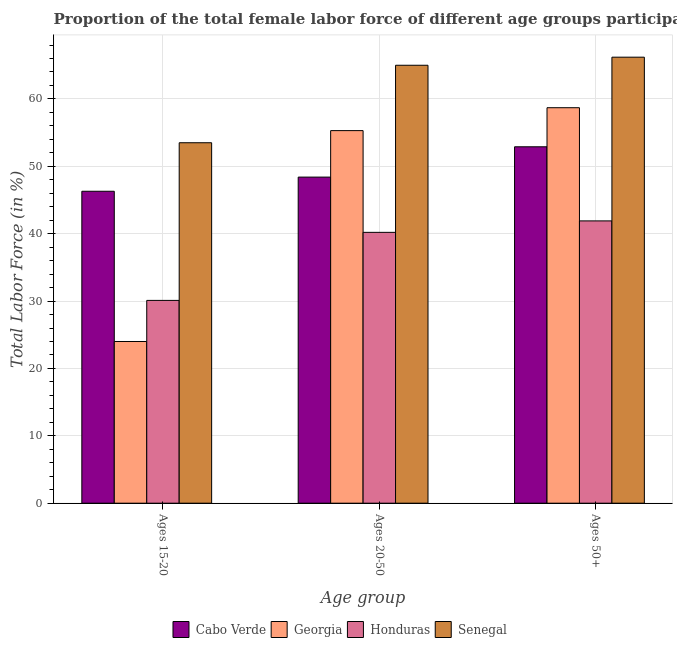Are the number of bars on each tick of the X-axis equal?
Your answer should be compact. Yes. How many bars are there on the 1st tick from the left?
Offer a terse response. 4. How many bars are there on the 3rd tick from the right?
Your answer should be compact. 4. What is the label of the 2nd group of bars from the left?
Provide a short and direct response. Ages 20-50. What is the percentage of female labor force within the age group 15-20 in Georgia?
Keep it short and to the point. 24. Across all countries, what is the maximum percentage of female labor force above age 50?
Provide a short and direct response. 66.2. Across all countries, what is the minimum percentage of female labor force above age 50?
Keep it short and to the point. 41.9. In which country was the percentage of female labor force above age 50 maximum?
Give a very brief answer. Senegal. In which country was the percentage of female labor force within the age group 15-20 minimum?
Keep it short and to the point. Georgia. What is the total percentage of female labor force above age 50 in the graph?
Offer a very short reply. 219.7. What is the difference between the percentage of female labor force within the age group 15-20 in Senegal and that in Georgia?
Provide a short and direct response. 29.5. What is the difference between the percentage of female labor force above age 50 in Georgia and the percentage of female labor force within the age group 15-20 in Cabo Verde?
Your response must be concise. 12.4. What is the average percentage of female labor force within the age group 15-20 per country?
Provide a short and direct response. 38.47. What is the difference between the percentage of female labor force above age 50 and percentage of female labor force within the age group 15-20 in Georgia?
Your answer should be very brief. 34.7. In how many countries, is the percentage of female labor force within the age group 15-20 greater than 6 %?
Ensure brevity in your answer.  4. What is the ratio of the percentage of female labor force within the age group 15-20 in Cabo Verde to that in Honduras?
Offer a very short reply. 1.54. Is the difference between the percentage of female labor force above age 50 in Senegal and Honduras greater than the difference between the percentage of female labor force within the age group 20-50 in Senegal and Honduras?
Offer a very short reply. No. What is the difference between the highest and the second highest percentage of female labor force within the age group 20-50?
Provide a short and direct response. 9.7. What is the difference between the highest and the lowest percentage of female labor force above age 50?
Your answer should be very brief. 24.3. Is the sum of the percentage of female labor force above age 50 in Senegal and Georgia greater than the maximum percentage of female labor force within the age group 20-50 across all countries?
Your response must be concise. Yes. What does the 4th bar from the left in Ages 15-20 represents?
Your response must be concise. Senegal. What does the 2nd bar from the right in Ages 15-20 represents?
Your response must be concise. Honduras. Is it the case that in every country, the sum of the percentage of female labor force within the age group 15-20 and percentage of female labor force within the age group 20-50 is greater than the percentage of female labor force above age 50?
Give a very brief answer. Yes. Are all the bars in the graph horizontal?
Make the answer very short. No. How many countries are there in the graph?
Your answer should be compact. 4. Are the values on the major ticks of Y-axis written in scientific E-notation?
Offer a terse response. No. Does the graph contain grids?
Keep it short and to the point. Yes. Where does the legend appear in the graph?
Your response must be concise. Bottom center. What is the title of the graph?
Offer a very short reply. Proportion of the total female labor force of different age groups participating in production in 2006. Does "Uzbekistan" appear as one of the legend labels in the graph?
Provide a succinct answer. No. What is the label or title of the X-axis?
Make the answer very short. Age group. What is the label or title of the Y-axis?
Offer a terse response. Total Labor Force (in %). What is the Total Labor Force (in %) of Cabo Verde in Ages 15-20?
Keep it short and to the point. 46.3. What is the Total Labor Force (in %) of Honduras in Ages 15-20?
Make the answer very short. 30.1. What is the Total Labor Force (in %) in Senegal in Ages 15-20?
Make the answer very short. 53.5. What is the Total Labor Force (in %) of Cabo Verde in Ages 20-50?
Your answer should be compact. 48.4. What is the Total Labor Force (in %) of Georgia in Ages 20-50?
Give a very brief answer. 55.3. What is the Total Labor Force (in %) in Honduras in Ages 20-50?
Offer a very short reply. 40.2. What is the Total Labor Force (in %) in Cabo Verde in Ages 50+?
Provide a succinct answer. 52.9. What is the Total Labor Force (in %) in Georgia in Ages 50+?
Provide a succinct answer. 58.7. What is the Total Labor Force (in %) of Honduras in Ages 50+?
Offer a very short reply. 41.9. What is the Total Labor Force (in %) in Senegal in Ages 50+?
Keep it short and to the point. 66.2. Across all Age group, what is the maximum Total Labor Force (in %) of Cabo Verde?
Ensure brevity in your answer.  52.9. Across all Age group, what is the maximum Total Labor Force (in %) in Georgia?
Your answer should be very brief. 58.7. Across all Age group, what is the maximum Total Labor Force (in %) in Honduras?
Keep it short and to the point. 41.9. Across all Age group, what is the maximum Total Labor Force (in %) in Senegal?
Offer a terse response. 66.2. Across all Age group, what is the minimum Total Labor Force (in %) of Cabo Verde?
Keep it short and to the point. 46.3. Across all Age group, what is the minimum Total Labor Force (in %) of Honduras?
Your answer should be compact. 30.1. Across all Age group, what is the minimum Total Labor Force (in %) in Senegal?
Provide a succinct answer. 53.5. What is the total Total Labor Force (in %) of Cabo Verde in the graph?
Provide a succinct answer. 147.6. What is the total Total Labor Force (in %) of Georgia in the graph?
Ensure brevity in your answer.  138. What is the total Total Labor Force (in %) in Honduras in the graph?
Provide a succinct answer. 112.2. What is the total Total Labor Force (in %) of Senegal in the graph?
Provide a succinct answer. 184.7. What is the difference between the Total Labor Force (in %) of Cabo Verde in Ages 15-20 and that in Ages 20-50?
Your answer should be very brief. -2.1. What is the difference between the Total Labor Force (in %) of Georgia in Ages 15-20 and that in Ages 20-50?
Offer a terse response. -31.3. What is the difference between the Total Labor Force (in %) in Honduras in Ages 15-20 and that in Ages 20-50?
Your answer should be compact. -10.1. What is the difference between the Total Labor Force (in %) of Senegal in Ages 15-20 and that in Ages 20-50?
Offer a terse response. -11.5. What is the difference between the Total Labor Force (in %) of Georgia in Ages 15-20 and that in Ages 50+?
Offer a terse response. -34.7. What is the difference between the Total Labor Force (in %) in Cabo Verde in Ages 20-50 and that in Ages 50+?
Give a very brief answer. -4.5. What is the difference between the Total Labor Force (in %) of Honduras in Ages 20-50 and that in Ages 50+?
Your answer should be compact. -1.7. What is the difference between the Total Labor Force (in %) of Senegal in Ages 20-50 and that in Ages 50+?
Provide a succinct answer. -1.2. What is the difference between the Total Labor Force (in %) in Cabo Verde in Ages 15-20 and the Total Labor Force (in %) in Honduras in Ages 20-50?
Ensure brevity in your answer.  6.1. What is the difference between the Total Labor Force (in %) in Cabo Verde in Ages 15-20 and the Total Labor Force (in %) in Senegal in Ages 20-50?
Make the answer very short. -18.7. What is the difference between the Total Labor Force (in %) in Georgia in Ages 15-20 and the Total Labor Force (in %) in Honduras in Ages 20-50?
Your answer should be compact. -16.2. What is the difference between the Total Labor Force (in %) in Georgia in Ages 15-20 and the Total Labor Force (in %) in Senegal in Ages 20-50?
Your answer should be very brief. -41. What is the difference between the Total Labor Force (in %) of Honduras in Ages 15-20 and the Total Labor Force (in %) of Senegal in Ages 20-50?
Offer a very short reply. -34.9. What is the difference between the Total Labor Force (in %) of Cabo Verde in Ages 15-20 and the Total Labor Force (in %) of Georgia in Ages 50+?
Provide a short and direct response. -12.4. What is the difference between the Total Labor Force (in %) in Cabo Verde in Ages 15-20 and the Total Labor Force (in %) in Honduras in Ages 50+?
Your response must be concise. 4.4. What is the difference between the Total Labor Force (in %) of Cabo Verde in Ages 15-20 and the Total Labor Force (in %) of Senegal in Ages 50+?
Ensure brevity in your answer.  -19.9. What is the difference between the Total Labor Force (in %) of Georgia in Ages 15-20 and the Total Labor Force (in %) of Honduras in Ages 50+?
Offer a very short reply. -17.9. What is the difference between the Total Labor Force (in %) of Georgia in Ages 15-20 and the Total Labor Force (in %) of Senegal in Ages 50+?
Offer a very short reply. -42.2. What is the difference between the Total Labor Force (in %) in Honduras in Ages 15-20 and the Total Labor Force (in %) in Senegal in Ages 50+?
Offer a very short reply. -36.1. What is the difference between the Total Labor Force (in %) of Cabo Verde in Ages 20-50 and the Total Labor Force (in %) of Honduras in Ages 50+?
Make the answer very short. 6.5. What is the difference between the Total Labor Force (in %) of Cabo Verde in Ages 20-50 and the Total Labor Force (in %) of Senegal in Ages 50+?
Offer a terse response. -17.8. What is the difference between the Total Labor Force (in %) in Georgia in Ages 20-50 and the Total Labor Force (in %) in Honduras in Ages 50+?
Offer a very short reply. 13.4. What is the difference between the Total Labor Force (in %) in Georgia in Ages 20-50 and the Total Labor Force (in %) in Senegal in Ages 50+?
Make the answer very short. -10.9. What is the average Total Labor Force (in %) of Cabo Verde per Age group?
Ensure brevity in your answer.  49.2. What is the average Total Labor Force (in %) of Honduras per Age group?
Give a very brief answer. 37.4. What is the average Total Labor Force (in %) in Senegal per Age group?
Provide a short and direct response. 61.57. What is the difference between the Total Labor Force (in %) of Cabo Verde and Total Labor Force (in %) of Georgia in Ages 15-20?
Offer a very short reply. 22.3. What is the difference between the Total Labor Force (in %) in Cabo Verde and Total Labor Force (in %) in Senegal in Ages 15-20?
Your answer should be compact. -7.2. What is the difference between the Total Labor Force (in %) of Georgia and Total Labor Force (in %) of Senegal in Ages 15-20?
Ensure brevity in your answer.  -29.5. What is the difference between the Total Labor Force (in %) of Honduras and Total Labor Force (in %) of Senegal in Ages 15-20?
Offer a very short reply. -23.4. What is the difference between the Total Labor Force (in %) of Cabo Verde and Total Labor Force (in %) of Senegal in Ages 20-50?
Give a very brief answer. -16.6. What is the difference between the Total Labor Force (in %) of Georgia and Total Labor Force (in %) of Honduras in Ages 20-50?
Ensure brevity in your answer.  15.1. What is the difference between the Total Labor Force (in %) in Honduras and Total Labor Force (in %) in Senegal in Ages 20-50?
Your answer should be very brief. -24.8. What is the difference between the Total Labor Force (in %) in Georgia and Total Labor Force (in %) in Honduras in Ages 50+?
Provide a succinct answer. 16.8. What is the difference between the Total Labor Force (in %) of Georgia and Total Labor Force (in %) of Senegal in Ages 50+?
Provide a succinct answer. -7.5. What is the difference between the Total Labor Force (in %) of Honduras and Total Labor Force (in %) of Senegal in Ages 50+?
Provide a short and direct response. -24.3. What is the ratio of the Total Labor Force (in %) in Cabo Verde in Ages 15-20 to that in Ages 20-50?
Offer a terse response. 0.96. What is the ratio of the Total Labor Force (in %) in Georgia in Ages 15-20 to that in Ages 20-50?
Offer a very short reply. 0.43. What is the ratio of the Total Labor Force (in %) of Honduras in Ages 15-20 to that in Ages 20-50?
Your response must be concise. 0.75. What is the ratio of the Total Labor Force (in %) in Senegal in Ages 15-20 to that in Ages 20-50?
Provide a succinct answer. 0.82. What is the ratio of the Total Labor Force (in %) of Cabo Verde in Ages 15-20 to that in Ages 50+?
Provide a short and direct response. 0.88. What is the ratio of the Total Labor Force (in %) in Georgia in Ages 15-20 to that in Ages 50+?
Your answer should be very brief. 0.41. What is the ratio of the Total Labor Force (in %) in Honduras in Ages 15-20 to that in Ages 50+?
Your answer should be very brief. 0.72. What is the ratio of the Total Labor Force (in %) of Senegal in Ages 15-20 to that in Ages 50+?
Keep it short and to the point. 0.81. What is the ratio of the Total Labor Force (in %) of Cabo Verde in Ages 20-50 to that in Ages 50+?
Offer a terse response. 0.91. What is the ratio of the Total Labor Force (in %) in Georgia in Ages 20-50 to that in Ages 50+?
Give a very brief answer. 0.94. What is the ratio of the Total Labor Force (in %) in Honduras in Ages 20-50 to that in Ages 50+?
Make the answer very short. 0.96. What is the ratio of the Total Labor Force (in %) of Senegal in Ages 20-50 to that in Ages 50+?
Keep it short and to the point. 0.98. What is the difference between the highest and the second highest Total Labor Force (in %) of Georgia?
Your answer should be compact. 3.4. What is the difference between the highest and the second highest Total Labor Force (in %) of Honduras?
Provide a succinct answer. 1.7. What is the difference between the highest and the second highest Total Labor Force (in %) of Senegal?
Your answer should be very brief. 1.2. What is the difference between the highest and the lowest Total Labor Force (in %) of Cabo Verde?
Provide a succinct answer. 6.6. What is the difference between the highest and the lowest Total Labor Force (in %) of Georgia?
Provide a short and direct response. 34.7. What is the difference between the highest and the lowest Total Labor Force (in %) in Honduras?
Offer a very short reply. 11.8. What is the difference between the highest and the lowest Total Labor Force (in %) in Senegal?
Your answer should be compact. 12.7. 